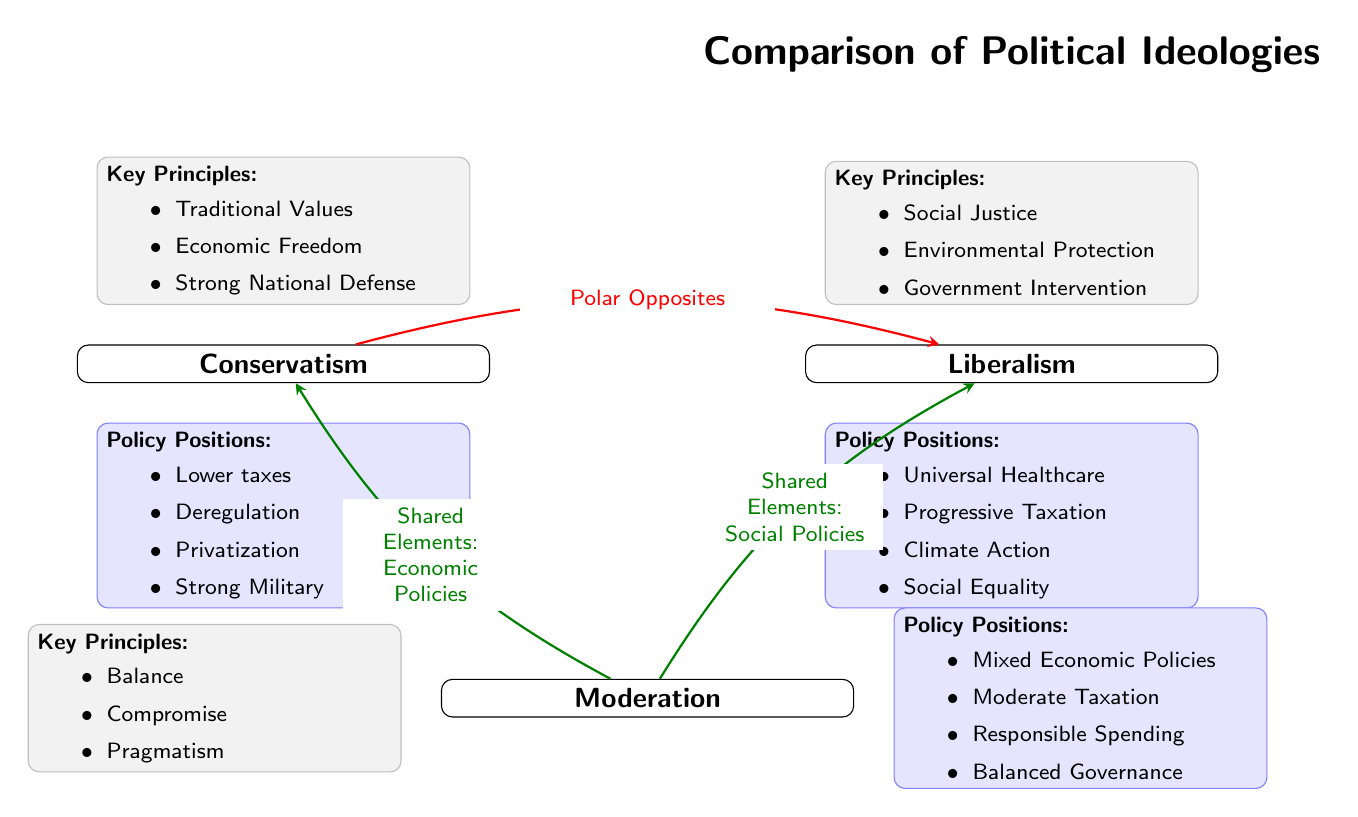What is the title of the diagram? The title is clearly stated at the top of the diagram and reads "Comparison of Political Ideologies".
Answer: Comparison of Political Ideologies How many ideologies are represented in the diagram? The diagram contains three ideologies: Conservatism, Liberalism, and Moderation. A count reveals that there are three main ideology nodes.
Answer: 3 What key principle is associated with Liberalism? The diagram lists "Social Justice" as one of the key principles under the Liberalism section.
Answer: Social Justice Which ideology emphasizes "Traditional Values"? The principle "Traditional Values" is explicitly listed under the Conservatism node, indicating that this ideology emphasizes it.
Answer: Conservatism What type of policy position is shared between Moderation and Liberalism? The diagram indicates that both Moderation and Liberalism share elements regarding "Social Policies", as shown by the connecting edge labeled as such.
Answer: Social Policies Name a policy position of Conservatism. Under the Conservatism section, "Lower taxes" is mentioned as one of the policy positions, which can be directly referenced from the list provided.
Answer: Lower taxes What principles does Moderation highlight? The key principles listed under Moderation include "Balance", "Compromise", and "Pragmatism", which can be found in the corresponding principles node.
Answer: Balance, Compromise, Pragmatism Which ideology is positioned as polar opposites to Conservatism? The edge labeled "Polar Opposites" connects Conservatism to Liberalism, establishing Liberalism as the opposing ideology.
Answer: Liberalism What does the arrow between Moderation and Conservatism indicate? The arrow labeled "Shared Elements: Economic Policies" indicates a relationship that signifies some commonality in economic policies between Moderation and Conservatism.
Answer: Shared Elements: Economic Policies 